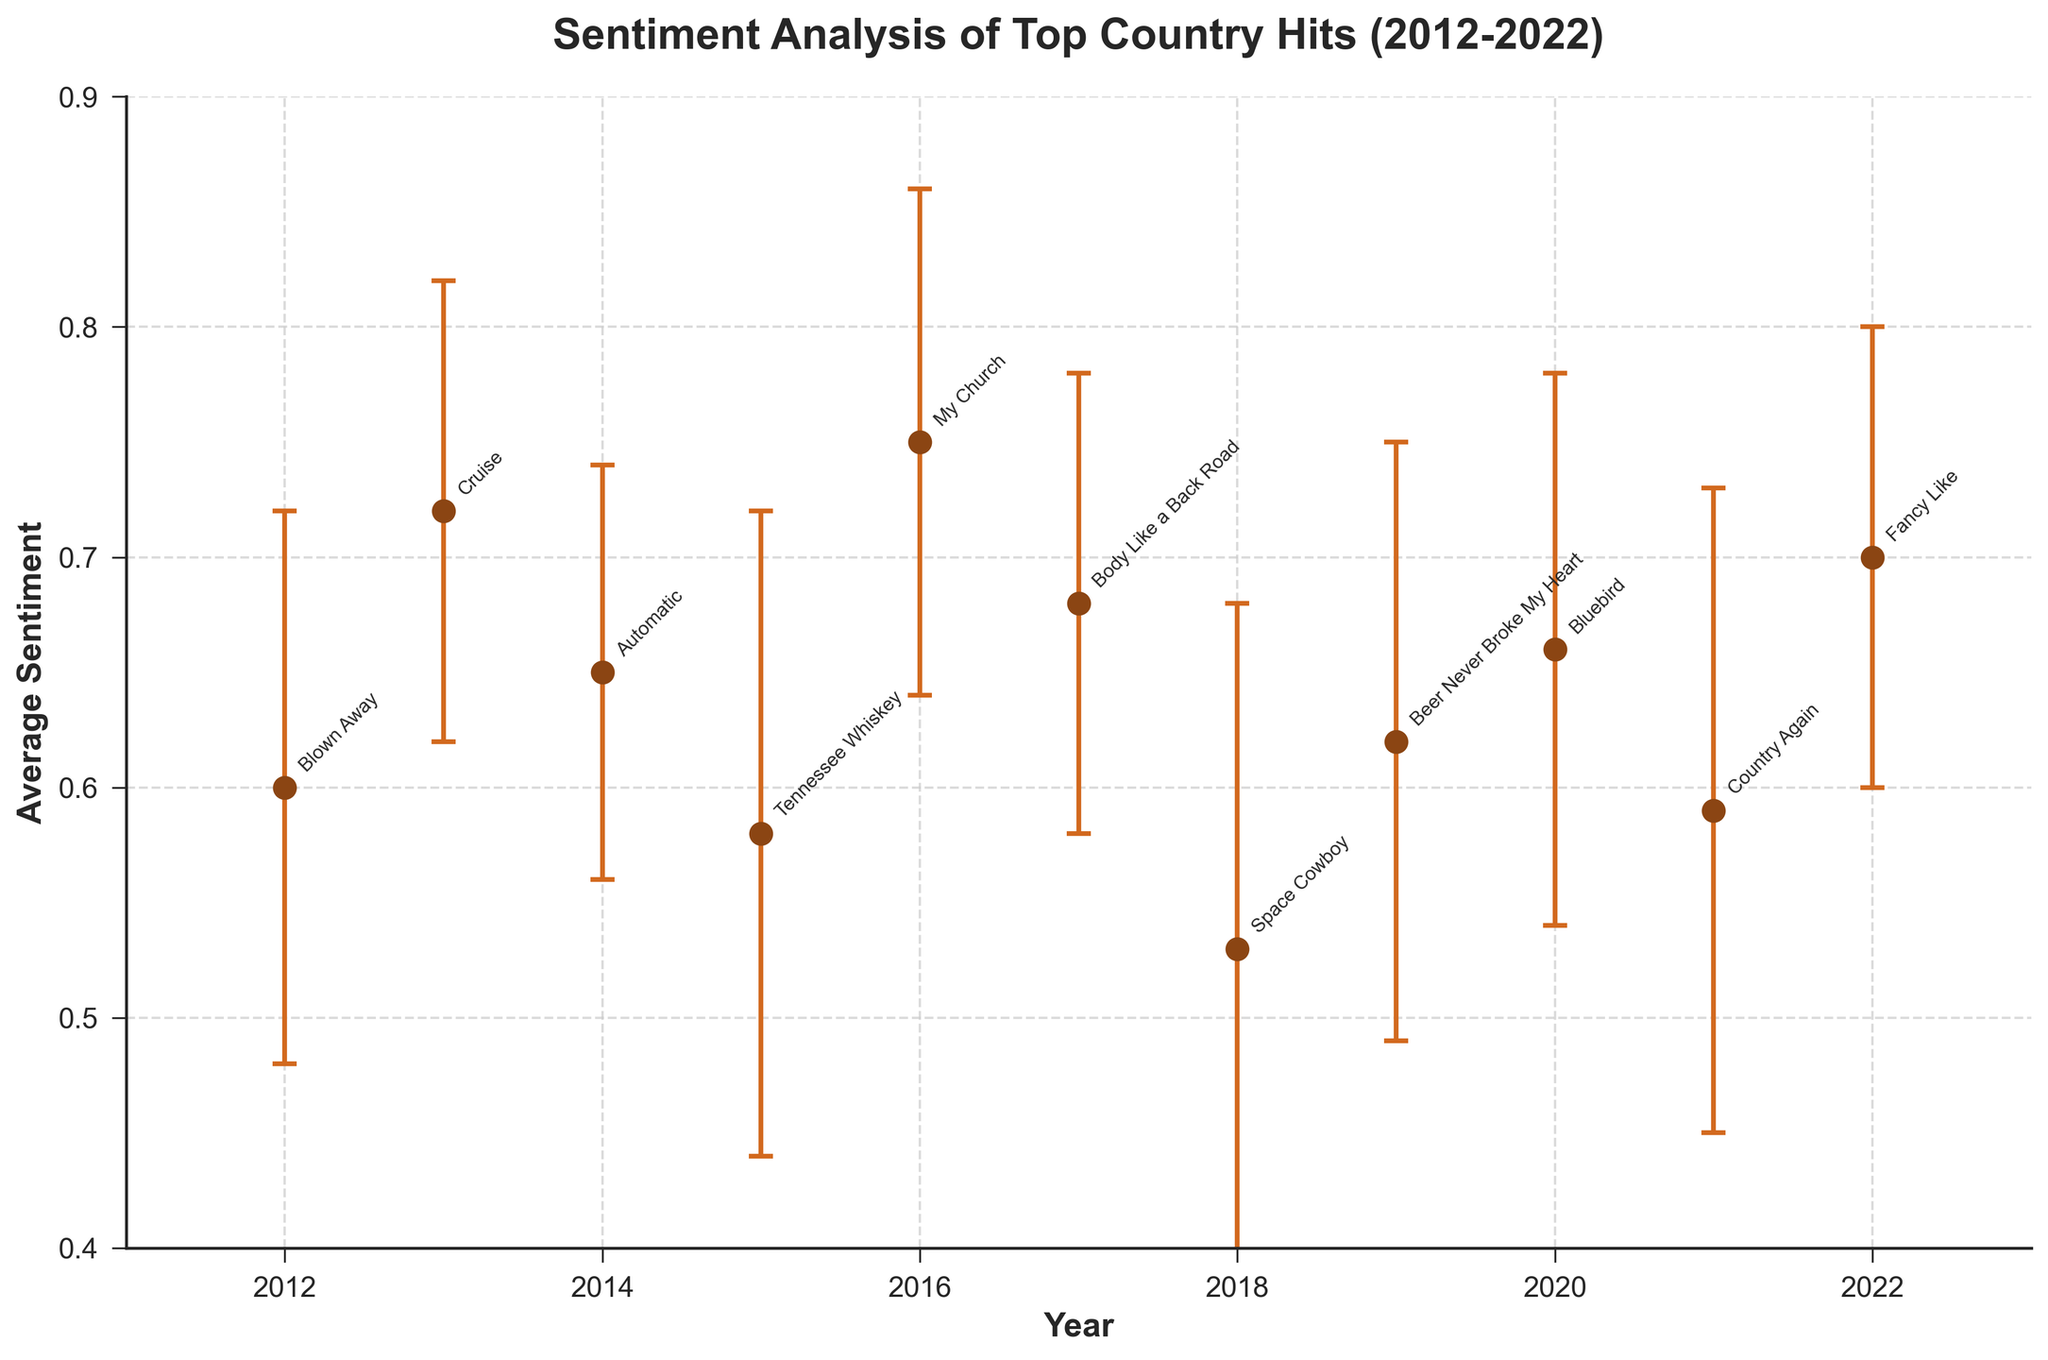What's the title of the figure? The title of the figure is written at the top and provides a summary of what the figure represents.
Answer: Sentiment Analysis of Top Country Hits (2012-2022) What is the average sentiment of the song "Tennessee Whiskey"? Locate the song "Tennessee Whiskey" on the figure, look at the corresponding average sentiment value.
Answer: 0.58 Which year has the highest average sentiment? Look for the dot that is the highest on the y-axis and find its corresponding year on the x-axis.
Answer: 2016 What is the range of average sentiment values in the plot? Identify the maximum and minimum average sentiment values from the dots and calculate the difference.
Answer: 0.53 to 0.75 Is there any year where the average sentiment is less than 0.6? Find all dots below the 0.6 mark on the y-axis and check their corresponding year.
Answer: 2015, 2018, 2021 Which song has the highest sentiment score, and what is the score? Locate the highest dot on the y-axis and find its corresponding song and average sentiment.
Answer: My Church, 0.75 Compare the sentiments of songs by Miranda Lambert from different years. Were they increasing or decreasing? Identify Miranda Lambert's songs, look at their positions and sentiments for the relevant years, and compare the values.
Answer: Increasing (2014: 0.65, 2020: 0.66) How do the sentiments of "Space Cowboy" and "Beer Never Broke My Heart" compare? Look at the y-axis positions of "Space Cowboy" and "Beer Never Broke My Heart" and compare their average sentiments.
Answer: "Space Cowboy" is 0.53, "Beer Never Broke My Heart" is 0.62; "Beer Never Broke My Heart" has a higher sentiment What is the average sentiment of the top country hits for the years 2017 and 2021 combined? Add the sentiment values for 2017 and 2021 and divide by 2 to find the average. (0.68 + 0.59) / 2
Answer: 0.635 